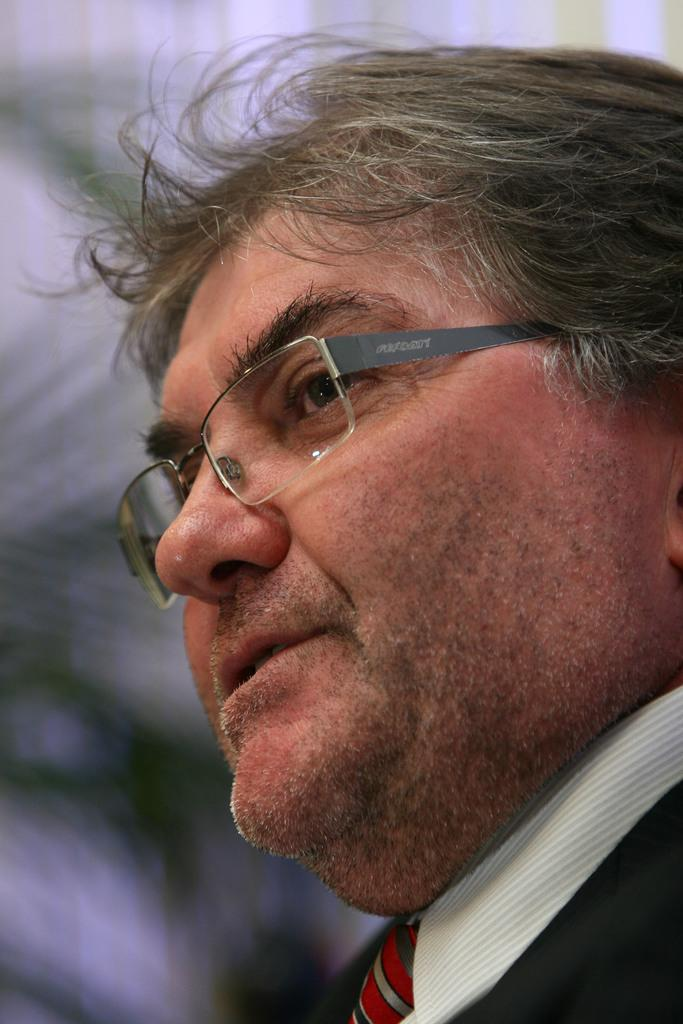What is the main subject of the image? There is a person in the image. Can you describe the background of the image? The background of the image is blurred. What type of wool is being used for pleasure in the image? There is no wool or indication of pleasure in the image; it features a person with a blurred background. 